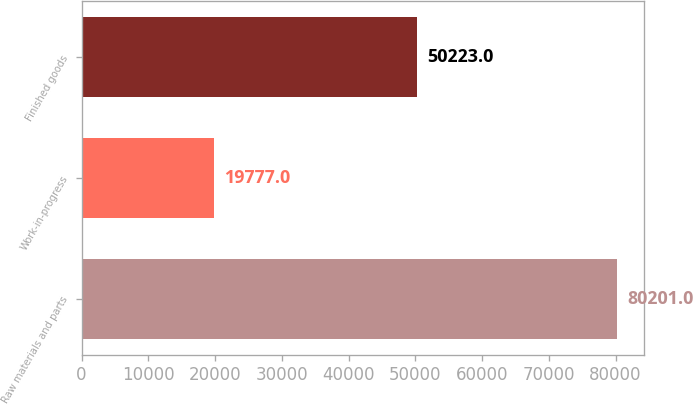Convert chart to OTSL. <chart><loc_0><loc_0><loc_500><loc_500><bar_chart><fcel>Raw materials and parts<fcel>Work-in-progress<fcel>Finished goods<nl><fcel>80201<fcel>19777<fcel>50223<nl></chart> 